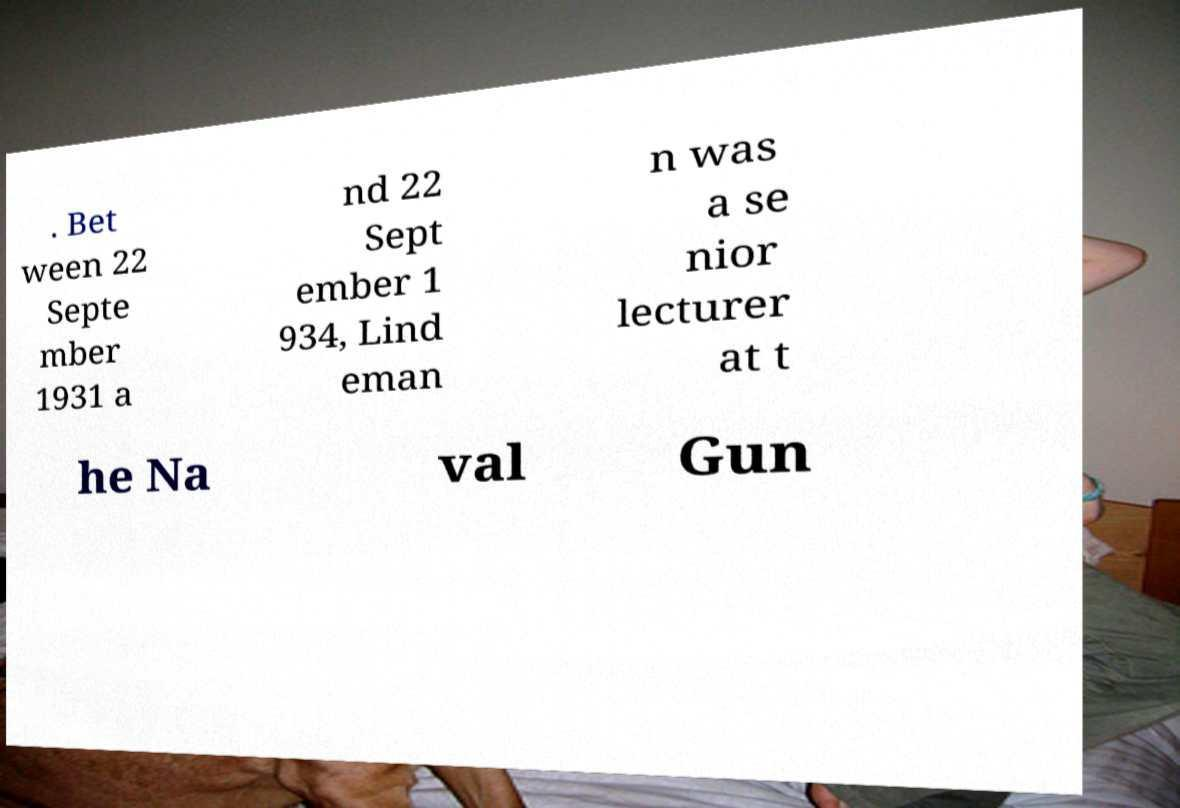For documentation purposes, I need the text within this image transcribed. Could you provide that? . Bet ween 22 Septe mber 1931 a nd 22 Sept ember 1 934, Lind eman n was a se nior lecturer at t he Na val Gun 